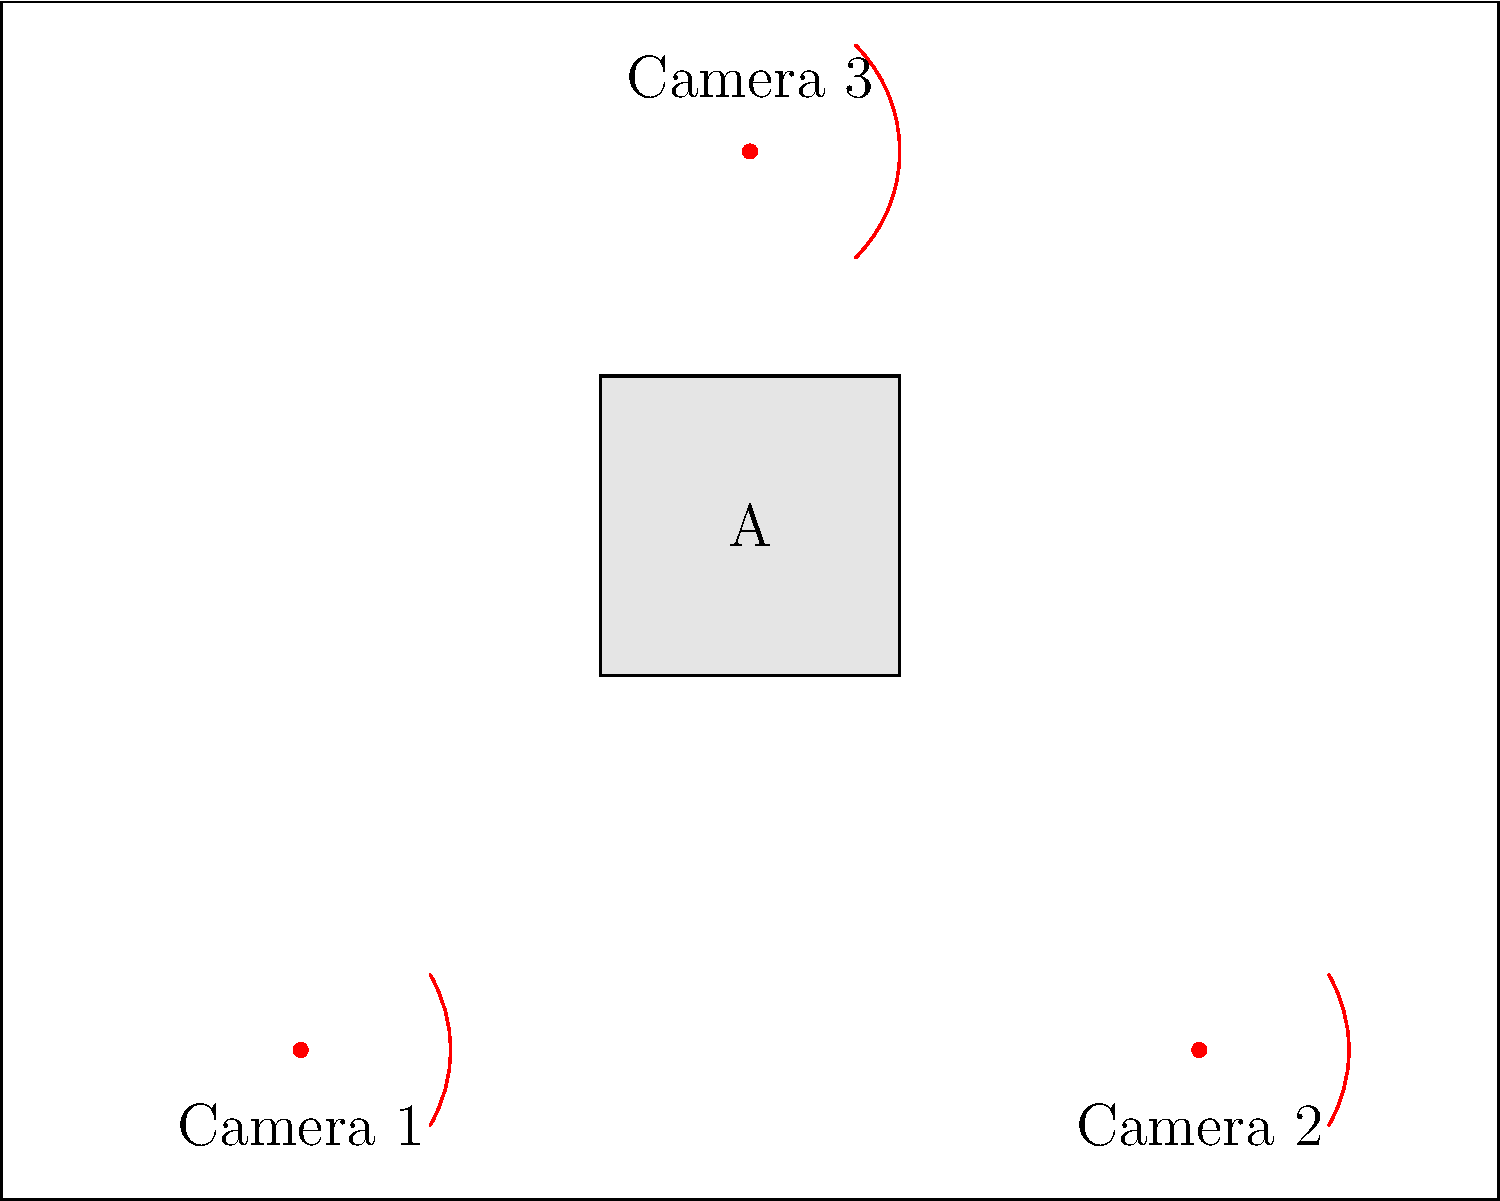In the given CCTV layout for a secure facility, which area marked 'A' represents a potential blind spot not covered by any of the three cameras? Explain how you determined this based on the camera positions and their fields of view. To identify the blind spot in this CCTV layout, we need to analyze the positions and fields of view of the three cameras:

1. Camera 1 (bottom left):
   - Position: (2,1)
   - Field of view: 60 degrees facing upward

2. Camera 2 (bottom right):
   - Position: (8,1)
   - Field of view: 60 degrees facing upward

3. Camera 3 (top center):
   - Position: (5,7)
   - Field of view: 90 degrees facing downward

Step-by-step analysis:
1. The room is rectangular, measuring 10 units wide and 8 units tall.
2. Camera 1's field of view covers the left side of the room but doesn't reach the top-right corner.
3. Camera 2's field of view covers the right side of the room but doesn't reach the top-left corner.
4. Camera 3's wider field of view (90 degrees) covers most of the upper part of the room.
5. However, there's a central area (marked 'A') that falls outside the coverage of all three cameras.

This area 'A' is approximately in the center of the room, slightly below the midpoint. It's not covered by Camera 1 or 2 because it's above their fields of view, and it's not covered by Camera 3 because it's below its field of view.

To improve coverage, potential solutions could include:
- Adjusting the angle of Camera 3 to point more downward
- Adding a fourth camera in the center of the room
- Using cameras with wider fields of view
Answer: Area A is a blind spot 